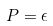Convert formula to latex. <formula><loc_0><loc_0><loc_500><loc_500>P = \epsilon</formula> 